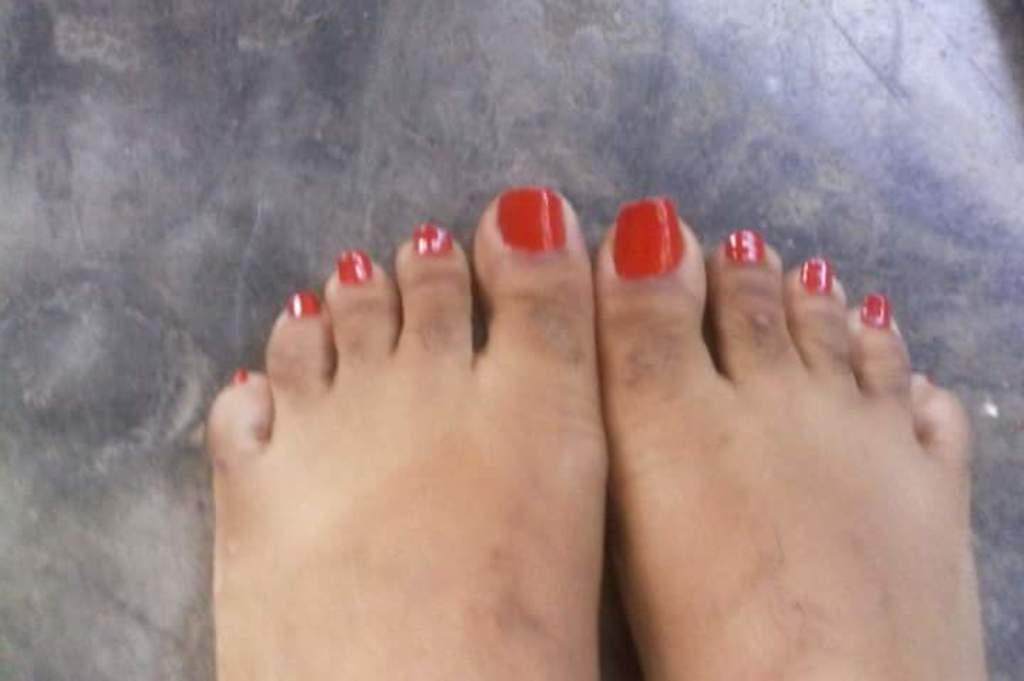What part of a person can be seen in the image? There are legs of a person visible in the image. What type of beef is being served on the sofa in the image? There is no beef or sofa present in the image; only the legs of a person are visible. 